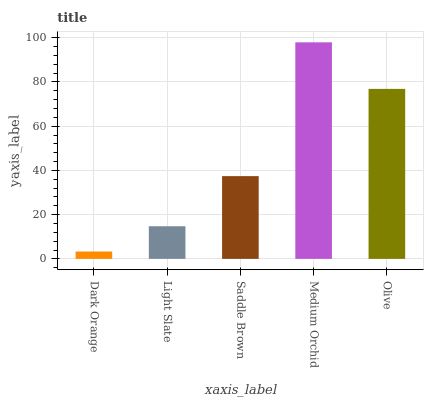Is Dark Orange the minimum?
Answer yes or no. Yes. Is Medium Orchid the maximum?
Answer yes or no. Yes. Is Light Slate the minimum?
Answer yes or no. No. Is Light Slate the maximum?
Answer yes or no. No. Is Light Slate greater than Dark Orange?
Answer yes or no. Yes. Is Dark Orange less than Light Slate?
Answer yes or no. Yes. Is Dark Orange greater than Light Slate?
Answer yes or no. No. Is Light Slate less than Dark Orange?
Answer yes or no. No. Is Saddle Brown the high median?
Answer yes or no. Yes. Is Saddle Brown the low median?
Answer yes or no. Yes. Is Medium Orchid the high median?
Answer yes or no. No. Is Light Slate the low median?
Answer yes or no. No. 